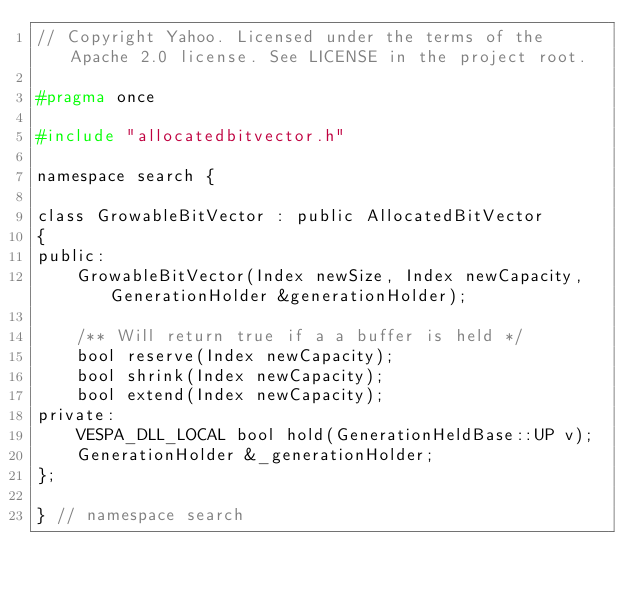<code> <loc_0><loc_0><loc_500><loc_500><_C_>// Copyright Yahoo. Licensed under the terms of the Apache 2.0 license. See LICENSE in the project root.

#pragma once

#include "allocatedbitvector.h"

namespace search {

class GrowableBitVector : public AllocatedBitVector
{
public:
    GrowableBitVector(Index newSize, Index newCapacity, GenerationHolder &generationHolder);

    /** Will return true if a a buffer is held */
    bool reserve(Index newCapacity);
    bool shrink(Index newCapacity);
    bool extend(Index newCapacity);
private:
    VESPA_DLL_LOCAL bool hold(GenerationHeldBase::UP v);
    GenerationHolder &_generationHolder;
};

} // namespace search

</code> 